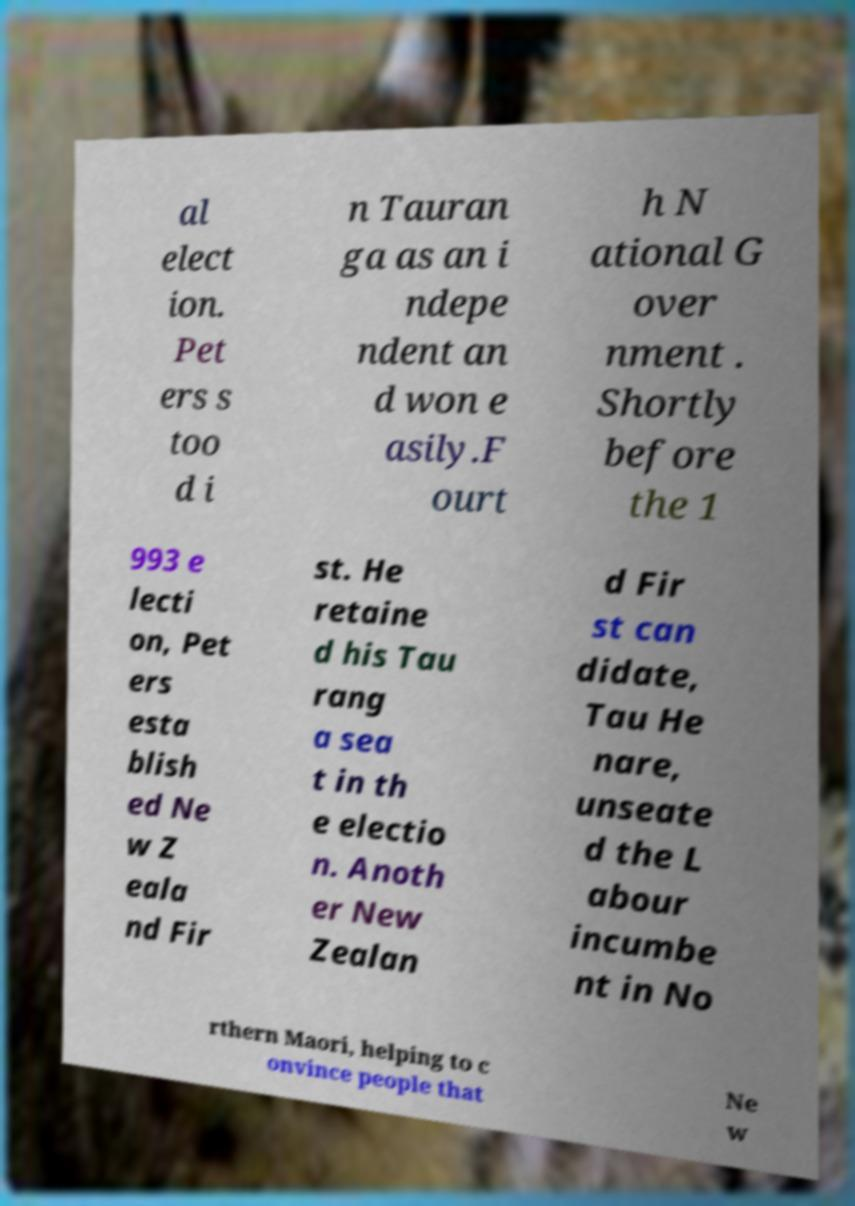What messages or text are displayed in this image? I need them in a readable, typed format. al elect ion. Pet ers s too d i n Tauran ga as an i ndepe ndent an d won e asily.F ourt h N ational G over nment . Shortly before the 1 993 e lecti on, Pet ers esta blish ed Ne w Z eala nd Fir st. He retaine d his Tau rang a sea t in th e electio n. Anoth er New Zealan d Fir st can didate, Tau He nare, unseate d the L abour incumbe nt in No rthern Maori, helping to c onvince people that Ne w 